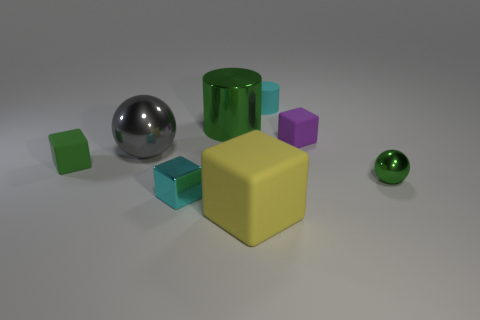Subtract all large yellow rubber cubes. How many cubes are left? 3 Subtract all gray spheres. How many spheres are left? 1 Subtract all green blocks. How many green spheres are left? 1 Add 1 tiny red rubber cylinders. How many objects exist? 9 Subtract all spheres. How many objects are left? 6 Subtract all blue cylinders. Subtract all gray spheres. How many cylinders are left? 2 Subtract all small cubes. Subtract all cylinders. How many objects are left? 3 Add 4 tiny spheres. How many tiny spheres are left? 5 Add 1 large gray objects. How many large gray objects exist? 2 Subtract 1 cyan cylinders. How many objects are left? 7 